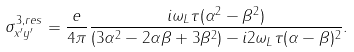Convert formula to latex. <formula><loc_0><loc_0><loc_500><loc_500>\sigma ^ { 3 , r e s } _ { x ^ { \prime } y ^ { \prime } } = \frac { e } { 4 \pi } \frac { i \omega _ { L } \tau ( \alpha ^ { 2 } - \beta ^ { 2 } ) } { ( 3 \alpha ^ { 2 } - 2 \alpha \beta + 3 \beta ^ { 2 } ) - i 2 \omega _ { L } \tau ( \alpha - \beta ) ^ { 2 } } .</formula> 